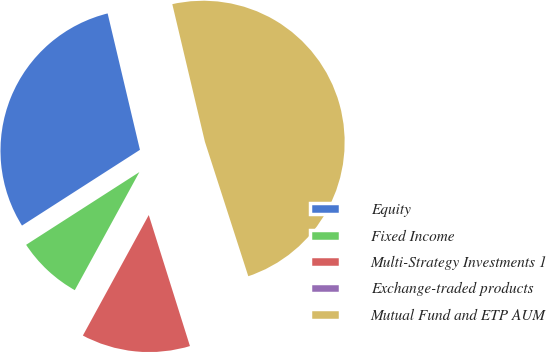Convert chart. <chart><loc_0><loc_0><loc_500><loc_500><pie_chart><fcel>Equity<fcel>Fixed Income<fcel>Multi-Strategy Investments 1<fcel>Exchange-traded products<fcel>Mutual Fund and ETP AUM<nl><fcel>30.38%<fcel>7.95%<fcel>12.81%<fcel>0.12%<fcel>48.73%<nl></chart> 